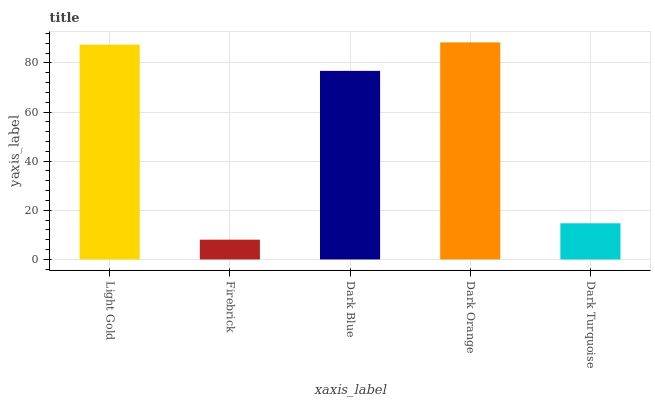Is Firebrick the minimum?
Answer yes or no. Yes. Is Dark Orange the maximum?
Answer yes or no. Yes. Is Dark Blue the minimum?
Answer yes or no. No. Is Dark Blue the maximum?
Answer yes or no. No. Is Dark Blue greater than Firebrick?
Answer yes or no. Yes. Is Firebrick less than Dark Blue?
Answer yes or no. Yes. Is Firebrick greater than Dark Blue?
Answer yes or no. No. Is Dark Blue less than Firebrick?
Answer yes or no. No. Is Dark Blue the high median?
Answer yes or no. Yes. Is Dark Blue the low median?
Answer yes or no. Yes. Is Light Gold the high median?
Answer yes or no. No. Is Dark Turquoise the low median?
Answer yes or no. No. 